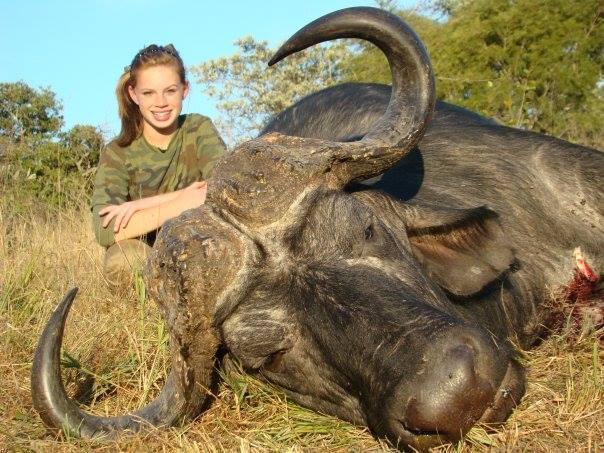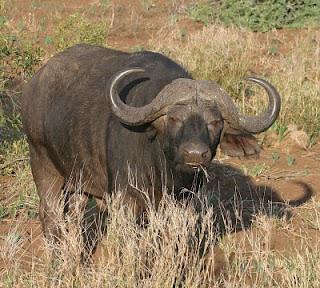The first image is the image on the left, the second image is the image on the right. Evaluate the accuracy of this statement regarding the images: "Left image shows one forward-facing water buffalo standing on dry ground.". Is it true? Answer yes or no. No. 